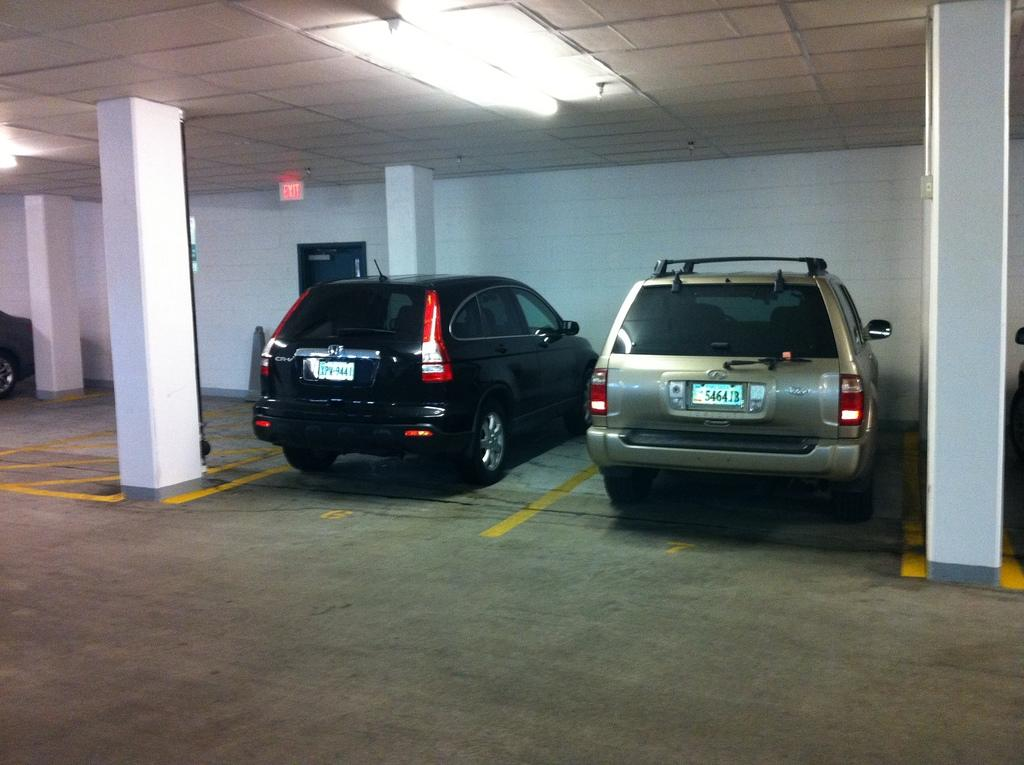How many cars are in the image? There are two cars in the image. Where are the cars located? The cars are parked in a cellar. What can be seen at the top of the image? There are lights visible at the top of the image. What supports the ceiling of the cellar? There are two pillars on either side of the cars. What type of frog can be seen hanging from an icicle in the image? There is no frog or icicle present in the image. How does the pollution affect the cars in the image? There is no mention of pollution in the image, so its effect on the cars cannot be determined. 